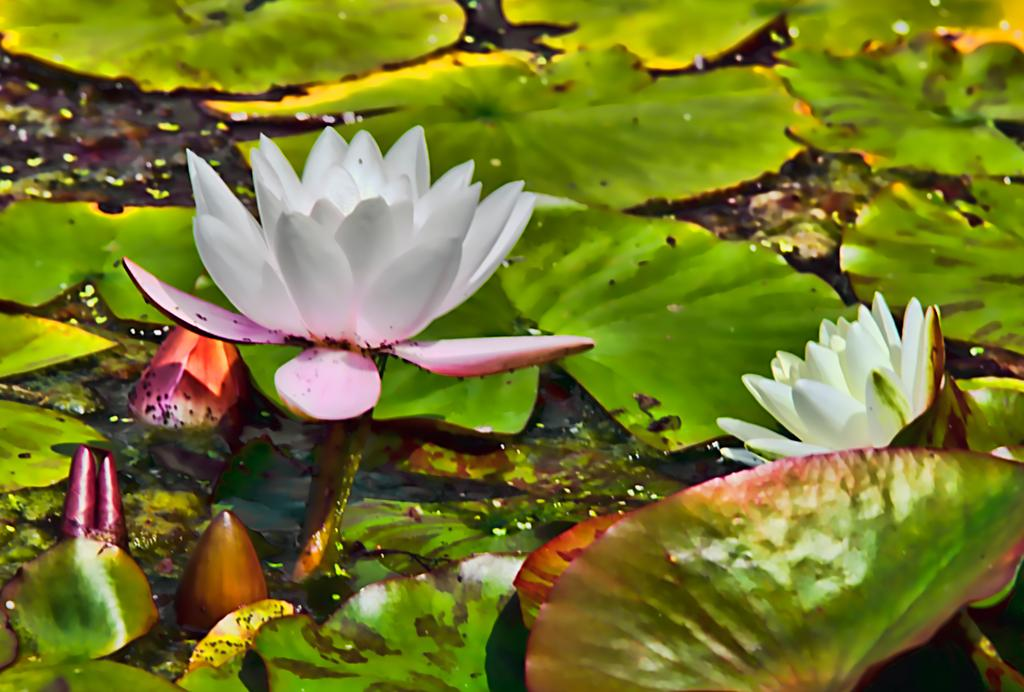What type of flowers are in the image? There are lotus flowers in the image. Where are the lotus flowers located? The lotus flowers are on the water. What other plant elements are visible in the image? There are green leaves in the image. How are the green leaves positioned in the image? The green leaves are floating on the water. What type of vegetable is being used as a fork in the image? There is no vegetable being used as a fork in the image. 